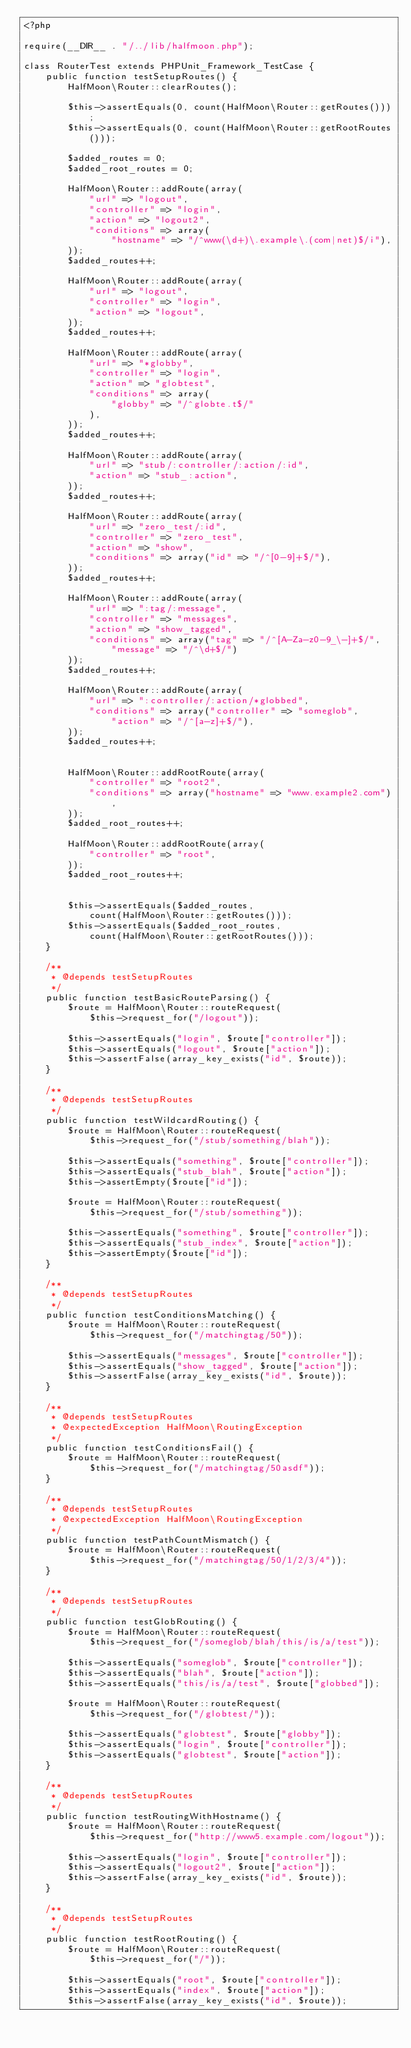<code> <loc_0><loc_0><loc_500><loc_500><_PHP_><?php

require(__DIR__ . "/../lib/halfmoon.php");

class RouterTest extends PHPUnit_Framework_TestCase {
	public function testSetupRoutes() {
		HalfMoon\Router::clearRoutes();

		$this->assertEquals(0, count(HalfMoon\Router::getRoutes()));
		$this->assertEquals(0, count(HalfMoon\Router::getRootRoutes()));

		$added_routes = 0;
		$added_root_routes = 0;

		HalfMoon\Router::addRoute(array(
			"url" => "logout",
			"controller" => "login",
			"action" => "logout2",
			"conditions" => array(
				"hostname" => "/^www(\d+)\.example\.(com|net)$/i"),
		));
		$added_routes++;

		HalfMoon\Router::addRoute(array(
			"url" => "logout",
			"controller" => "login",
			"action" => "logout",
		));
		$added_routes++;

		HalfMoon\Router::addRoute(array(
			"url" => "*globby",
			"controller" => "login",
			"action" => "globtest",
			"conditions" => array(
				"globby" => "/^globte.t$/"
			),
		));
		$added_routes++;

		HalfMoon\Router::addRoute(array(
			"url" => "stub/:controller/:action/:id",
			"action" => "stub_:action",
		));
		$added_routes++;

		HalfMoon\Router::addRoute(array(
			"url" => "zero_test/:id",
			"controller" => "zero_test",
			"action" => "show",
			"conditions" => array("id" => "/^[0-9]+$/"),
		));
		$added_routes++;

		HalfMoon\Router::addRoute(array(
			"url" => ":tag/:message",
			"controller" => "messages",
			"action" => "show_tagged",
			"conditions" => array("tag" => "/^[A-Za-z0-9_\-]+$/",
				"message" => "/^\d+$/")
		));
		$added_routes++;

		HalfMoon\Router::addRoute(array(
			"url" => ":controller/:action/*globbed",
			"conditions" => array("controller" => "someglob",
				"action" => "/^[a-z]+$/"),
		));
		$added_routes++;


		HalfMoon\Router::addRootRoute(array(
			"controller" => "root2",
			"conditions" => array("hostname" => "www.example2.com"),
		));
		$added_root_routes++;

		HalfMoon\Router::addRootRoute(array(
			"controller" => "root",
		));
		$added_root_routes++;


		$this->assertEquals($added_routes,
			count(HalfMoon\Router::getRoutes()));
		$this->assertEquals($added_root_routes,
			count(HalfMoon\Router::getRootRoutes()));
	}

	/**
	 * @depends testSetupRoutes
	 */
    public function testBasicRouteParsing() {
		$route = HalfMoon\Router::routeRequest(
			$this->request_for("/logout"));

		$this->assertEquals("login", $route["controller"]);
		$this->assertEquals("logout", $route["action"]);
		$this->assertFalse(array_key_exists("id", $route));
    }

	/**
	 * @depends testSetupRoutes
	 */
    public function testWildcardRouting() {
		$route = HalfMoon\Router::routeRequest(
			$this->request_for("/stub/something/blah"));

		$this->assertEquals("something", $route["controller"]);
		$this->assertEquals("stub_blah", $route["action"]);
		$this->assertEmpty($route["id"]);

		$route = HalfMoon\Router::routeRequest(
			$this->request_for("/stub/something"));

		$this->assertEquals("something", $route["controller"]);
		$this->assertEquals("stub_index", $route["action"]);
		$this->assertEmpty($route["id"]);
    }

	/**
	 * @depends testSetupRoutes
	 */
    public function testConditionsMatching() {
		$route = HalfMoon\Router::routeRequest(
			$this->request_for("/matchingtag/50"));

		$this->assertEquals("messages", $route["controller"]);
		$this->assertEquals("show_tagged", $route["action"]);
		$this->assertFalse(array_key_exists("id", $route));
	}

	/**
	 * @depends testSetupRoutes
     * @expectedException HalfMoon\RoutingException
	 */
    public function testConditionsFail() {
		$route = HalfMoon\Router::routeRequest(
			$this->request_for("/matchingtag/50asdf"));
	}

	/**
	 * @depends testSetupRoutes
     * @expectedException HalfMoon\RoutingException
	 */
    public function testPathCountMismatch() {
		$route = HalfMoon\Router::routeRequest(
			$this->request_for("/matchingtag/50/1/2/3/4"));
	}

	/**
	 * @depends testSetupRoutes
	 */
    public function testGlobRouting() {
		$route = HalfMoon\Router::routeRequest(
			$this->request_for("/someglob/blah/this/is/a/test"));

		$this->assertEquals("someglob", $route["controller"]);
		$this->assertEquals("blah", $route["action"]);
		$this->assertEquals("this/is/a/test", $route["globbed"]);

		$route = HalfMoon\Router::routeRequest(
			$this->request_for("/globtest/"));

		$this->assertEquals("globtest", $route["globby"]);
		$this->assertEquals("login", $route["controller"]);
		$this->assertEquals("globtest", $route["action"]);
	}

	/**
	 * @depends testSetupRoutes
	 */
    public function testRoutingWithHostname() {
		$route = HalfMoon\Router::routeRequest(
			$this->request_for("http://www5.example.com/logout"));

		$this->assertEquals("login", $route["controller"]);
		$this->assertEquals("logout2", $route["action"]);
		$this->assertFalse(array_key_exists("id", $route));
    }

	/**
	 * @depends testSetupRoutes
	 */
    public function testRootRouting() {
		$route = HalfMoon\Router::routeRequest(
			$this->request_for("/"));

		$this->assertEquals("root", $route["controller"]);
		$this->assertEquals("index", $route["action"]);
		$this->assertFalse(array_key_exists("id", $route));</code> 